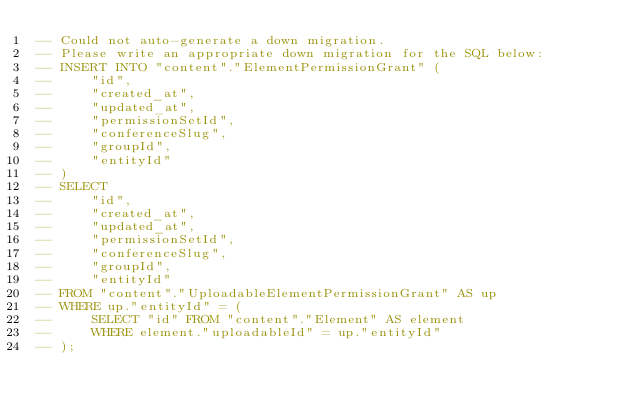Convert code to text. <code><loc_0><loc_0><loc_500><loc_500><_SQL_>-- Could not auto-generate a down migration.
-- Please write an appropriate down migration for the SQL below:
-- INSERT INTO "content"."ElementPermissionGrant" (
--     "id",
--     "created_at",
--     "updated_at",
--     "permissionSetId",
--     "conferenceSlug",
--     "groupId",
--     "entityId"
-- )
-- SELECT
--     "id",
--     "created_at",
--     "updated_at",
--     "permissionSetId",
--     "conferenceSlug",
--     "groupId",
--     "entityId"
-- FROM "content"."UploadableElementPermissionGrant" AS up
-- WHERE up."entityId" = (
--     SELECT "id" FROM "content"."Element" AS element
--     WHERE element."uploadableId" = up."entityId"
-- );
</code> 